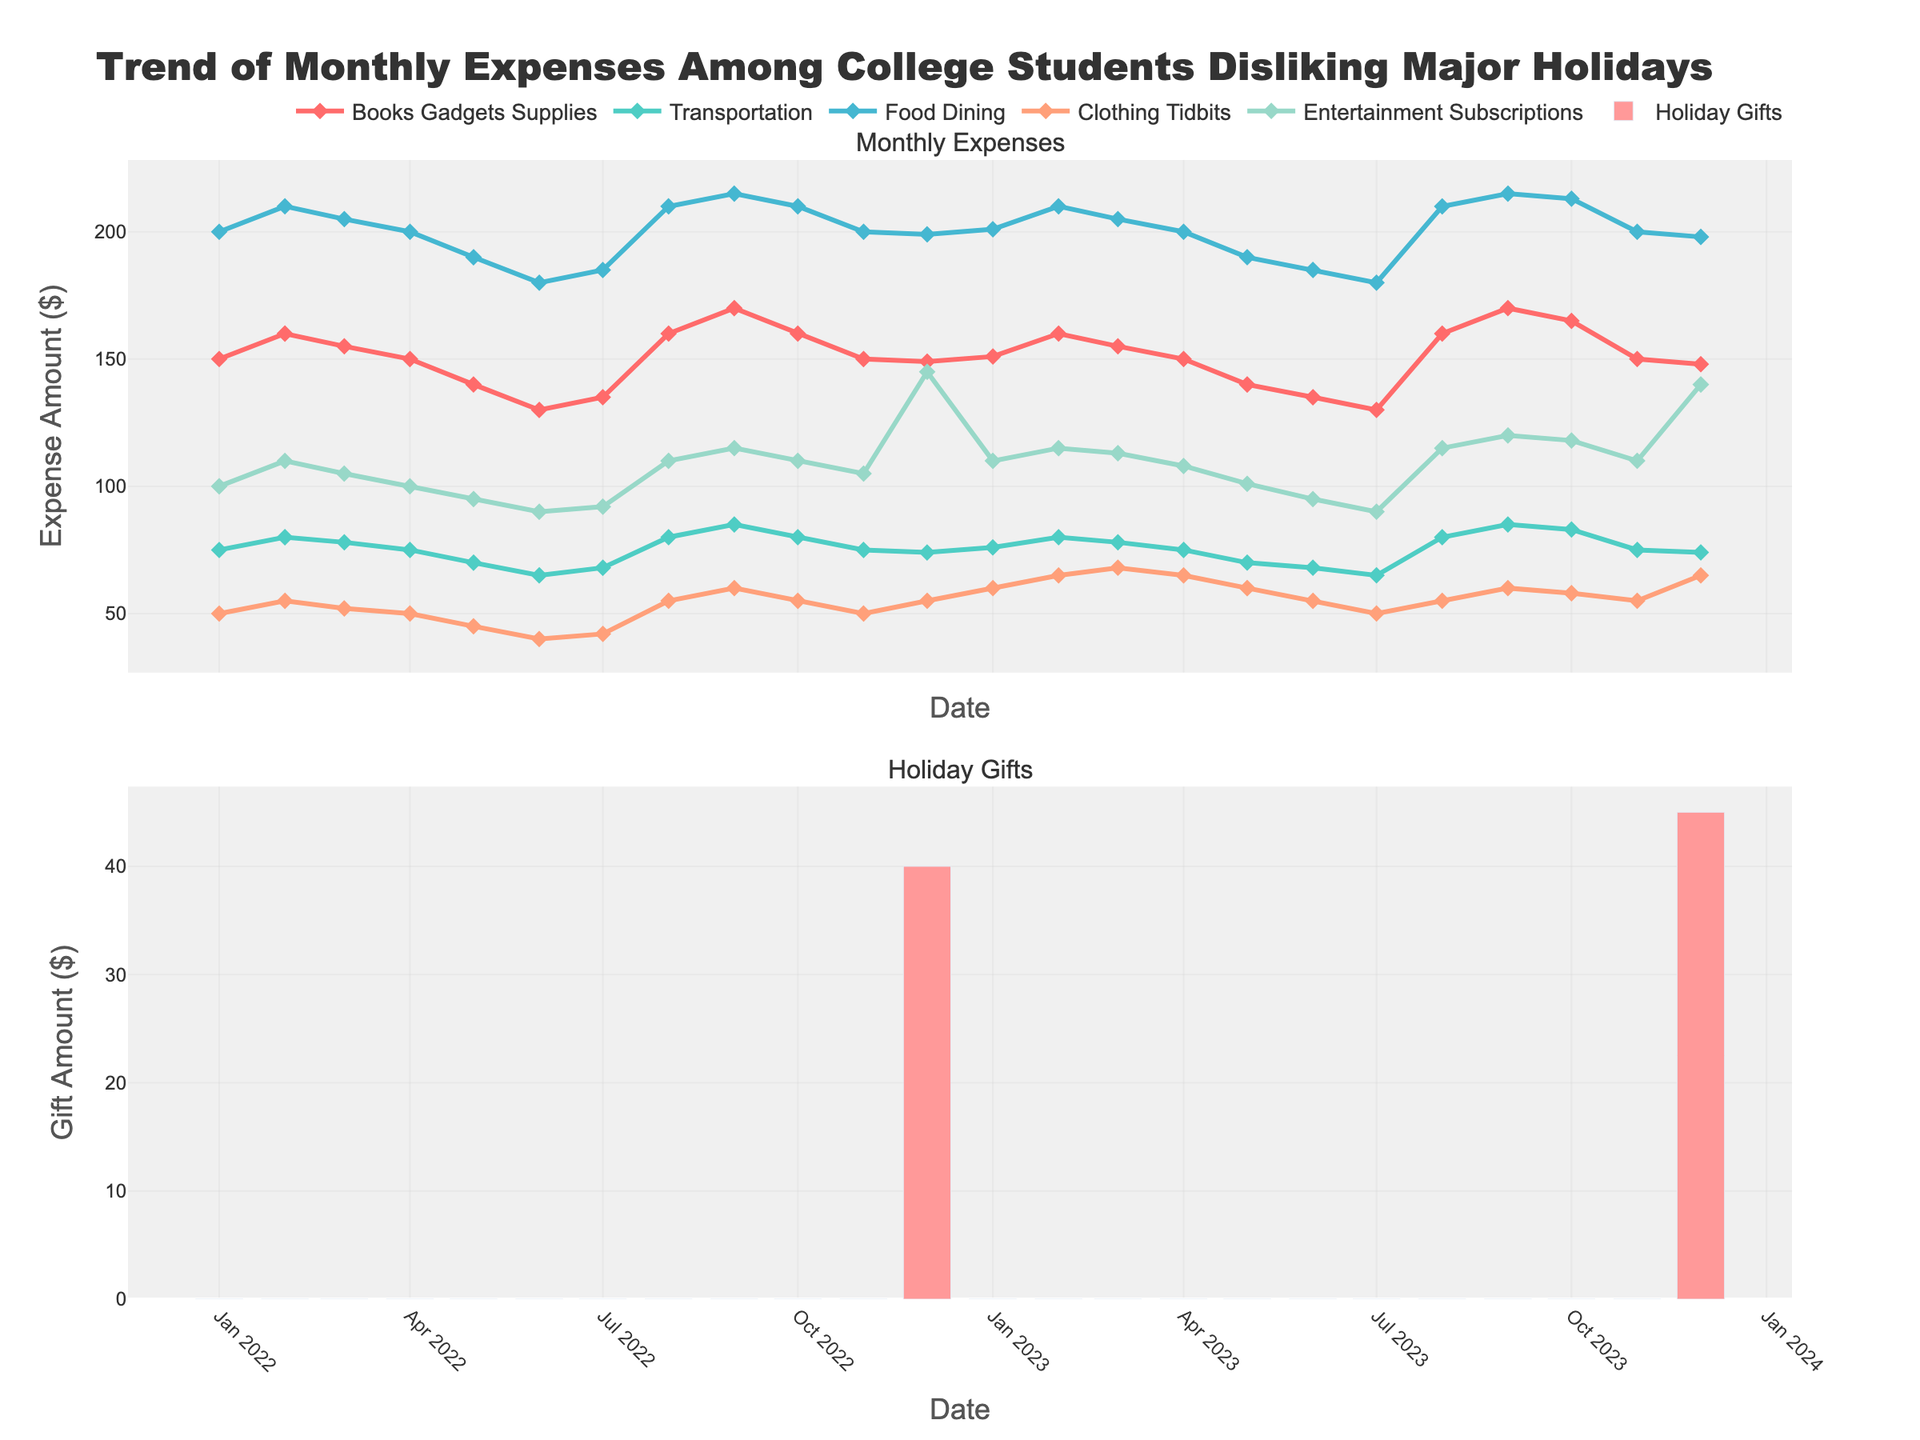What's the title of the figure? The title is located at the top of the figure and provides a summary of the visualization's content.
Answer: Trend of Monthly Expenses Among College Students Disliking Major Holidays What are the two subplots shown in the figure? The figure has two subplots titled "Monthly Expenses" and "Holiday Gifts." The titles are given above each subplot.
Answer: Monthly Expenses, Holiday Gifts Which category shows the highest expense in August 2022? Looking at the August 2022 data points in the first subplot, the highest y-value corresponds to the "Food Dining" category.
Answer: Food Dining What is the lowest transportation expense recorded, and in which month? The lowest y-value in the Transportation category has to be identified. It appears in June 2023 and July 2023 at the value of $65.
Answer: $65, June 2023, July 2023 How do the holiday gift expenses in December 2022 and December 2023 compare? By examining the holiday gift expenses in both Decembers, we see that December 2022 is $40 and December 2023 is $45.
Answer: December 2023 is higher than December 2022 Compare the trend of food dining expenses between 2022 and 2023. By examining the "Food Dining" line across the two years, we see that the expenses for food dining are generally stable but show a slight increase towards the end of 2023.
Answer: Slight increase in 2023 What is the average expense for clothing tidbits in 2023? Sum all the clothing tidbits values for 2023 (60 + 65 + 68 + 65 + 60 + 55 + 50 + 55 + 60 + 58 + 65) and divide by 11. Total = 671. Average = 671/11 = 61.
Answer: 61 How many times do the entertainment subscriptions expenses reach $110? By checking the data points, the entertainment subscriptions expense reaches $110 in January 2022, October 2022, January 2023, and November 2023.
Answer: 4 Which month in 2023 shows the highest expense for books, gadgets, and supplies? Looking at the "Books_Gadgets_Supplies" category in 2023, the month with the highest value is September 2023, with an expense of $170.
Answer: September 2023 Is there any month where the expenses for books, gadgets, and supplies and holiday gifts both show spikes at the same time? By carefully examining the data points for both categories, we see this occurs in December 2023.
Answer: December 2023 